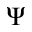<formula> <loc_0><loc_0><loc_500><loc_500>\Psi</formula> 